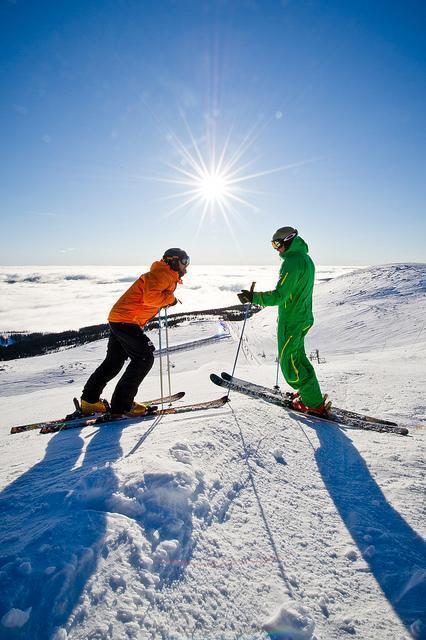How many ski are there?
Give a very brief answer. 2. How many people are in the photo?
Give a very brief answer. 2. 